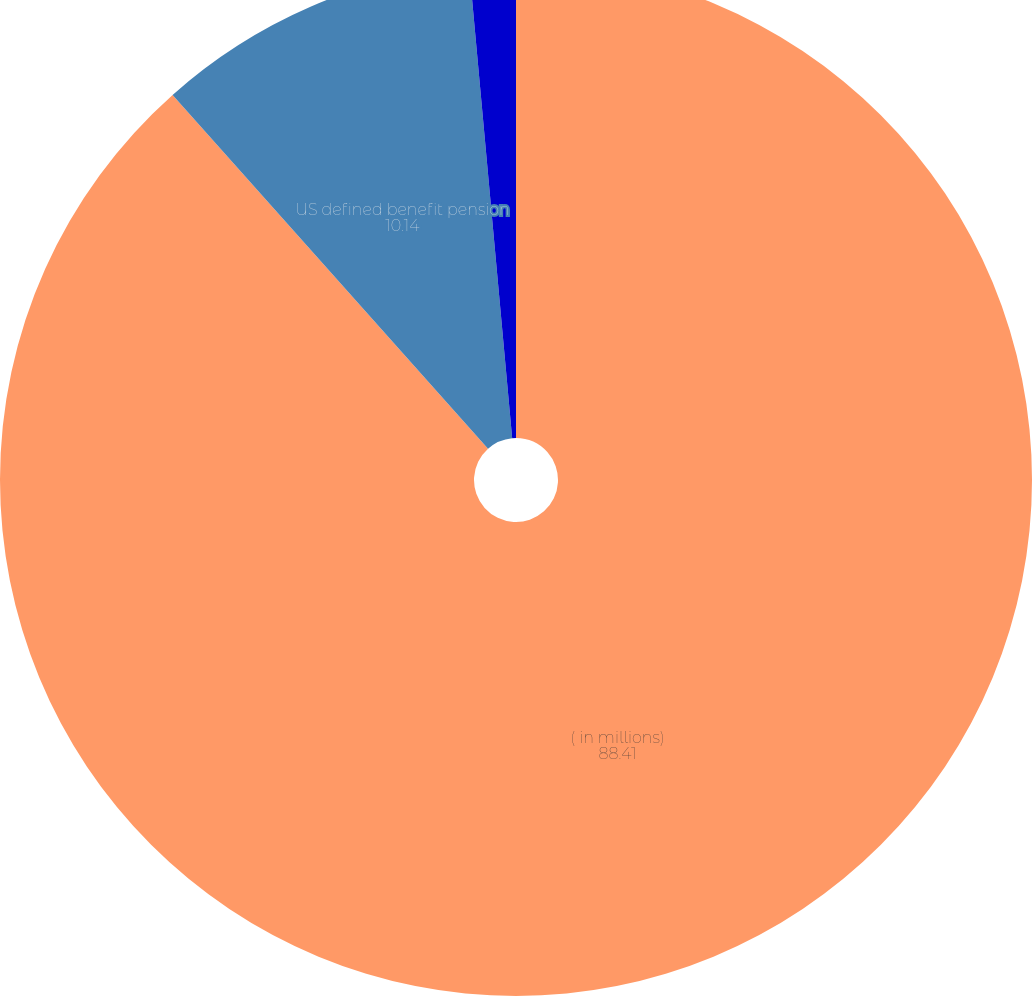<chart> <loc_0><loc_0><loc_500><loc_500><pie_chart><fcel>( in millions)<fcel>US defined benefit pension<fcel>Non-US defined benefit pension<nl><fcel>88.41%<fcel>10.14%<fcel>1.45%<nl></chart> 